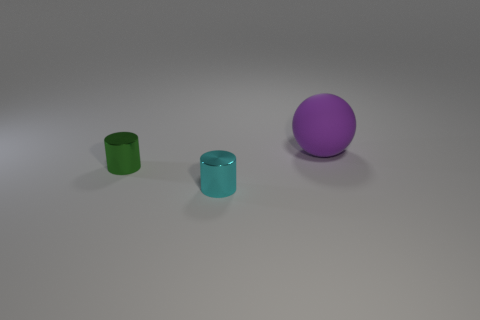Add 3 cylinders. How many objects exist? 6 Subtract all spheres. How many objects are left? 2 Subtract all gray shiny objects. Subtract all purple rubber things. How many objects are left? 2 Add 1 small cyan shiny objects. How many small cyan shiny objects are left? 2 Add 2 tiny cyan objects. How many tiny cyan objects exist? 3 Subtract 0 brown cubes. How many objects are left? 3 